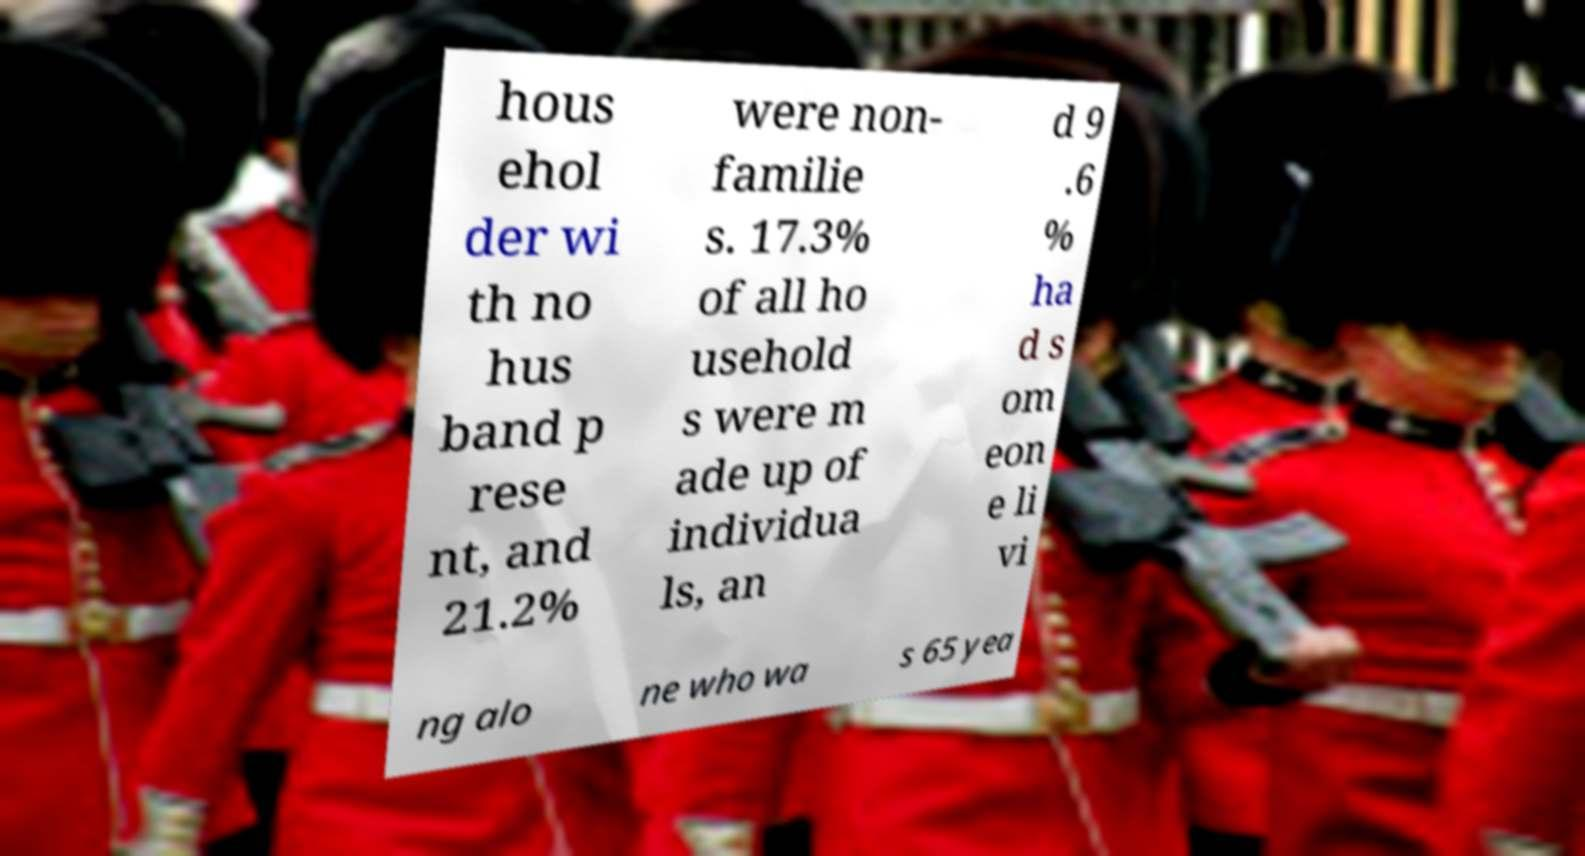Please identify and transcribe the text found in this image. hous ehol der wi th no hus band p rese nt, and 21.2% were non- familie s. 17.3% of all ho usehold s were m ade up of individua ls, an d 9 .6 % ha d s om eon e li vi ng alo ne who wa s 65 yea 